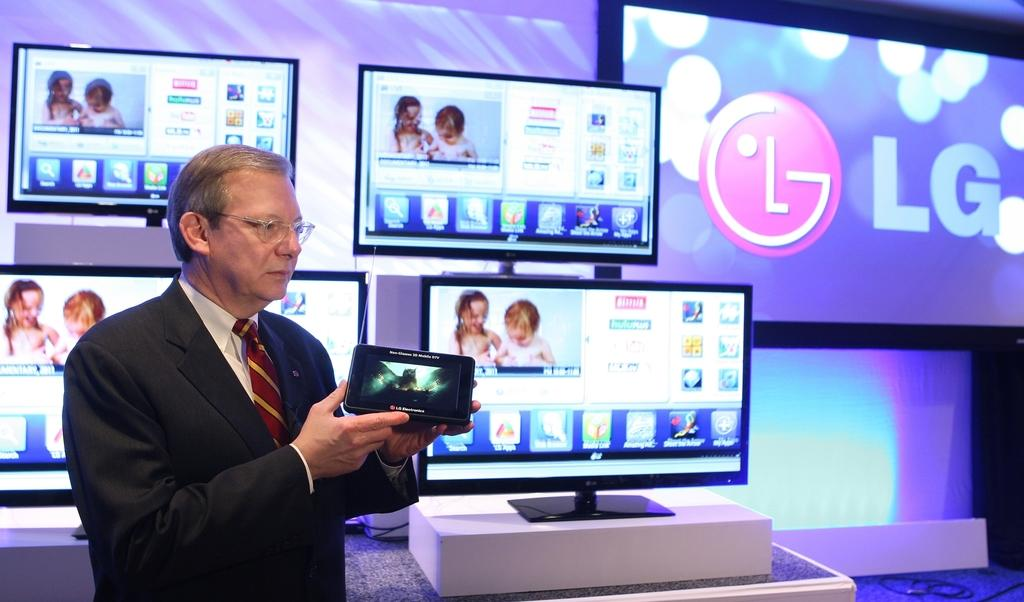Provide a one-sentence caption for the provided image. Man displaying and showing a screen of an LG product. 